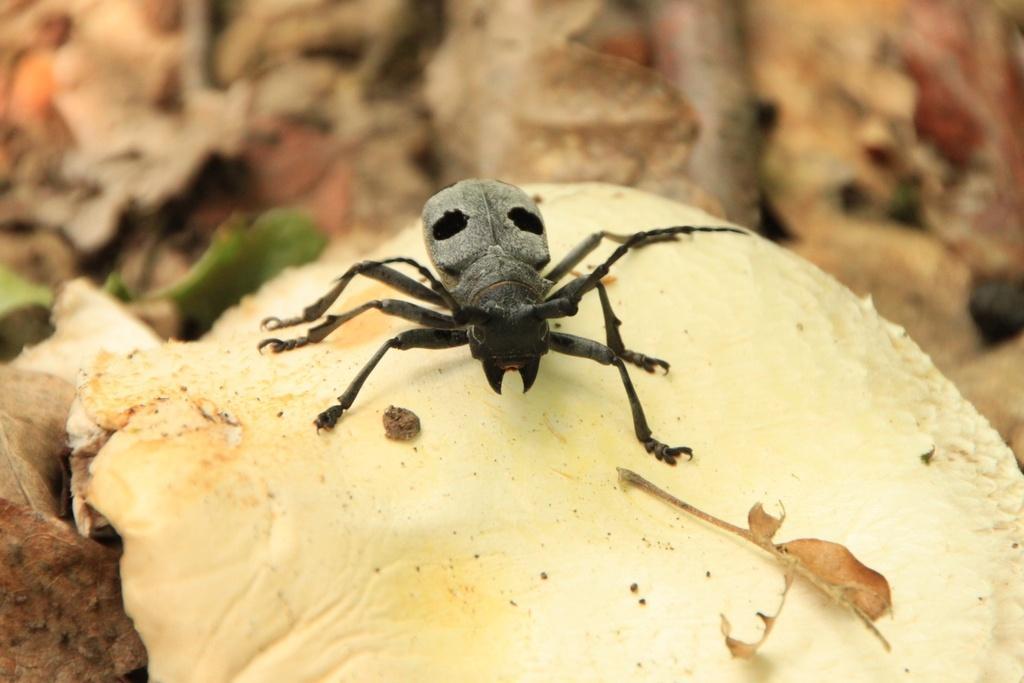In one or two sentences, can you explain what this image depicts? In this image, in the middle, we can see a insect which is on the mushroom. On the left side, we can see a mushroom. In the background, we can see brown color. 